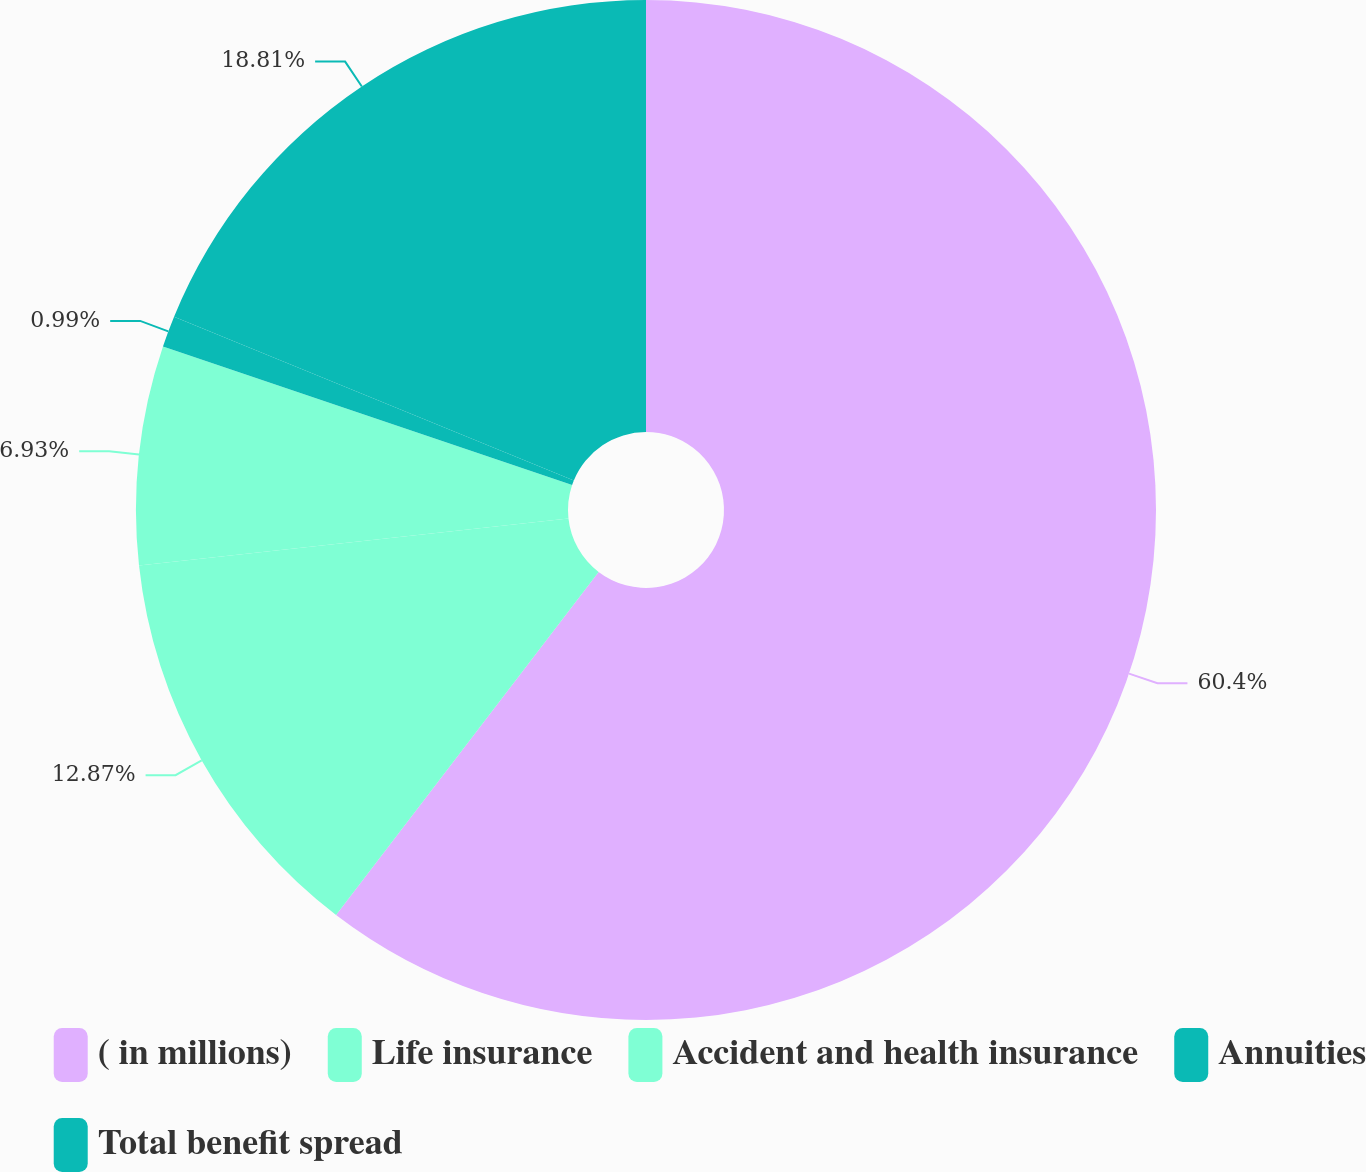Convert chart. <chart><loc_0><loc_0><loc_500><loc_500><pie_chart><fcel>( in millions)<fcel>Life insurance<fcel>Accident and health insurance<fcel>Annuities<fcel>Total benefit spread<nl><fcel>60.39%<fcel>12.87%<fcel>6.93%<fcel>0.99%<fcel>18.81%<nl></chart> 